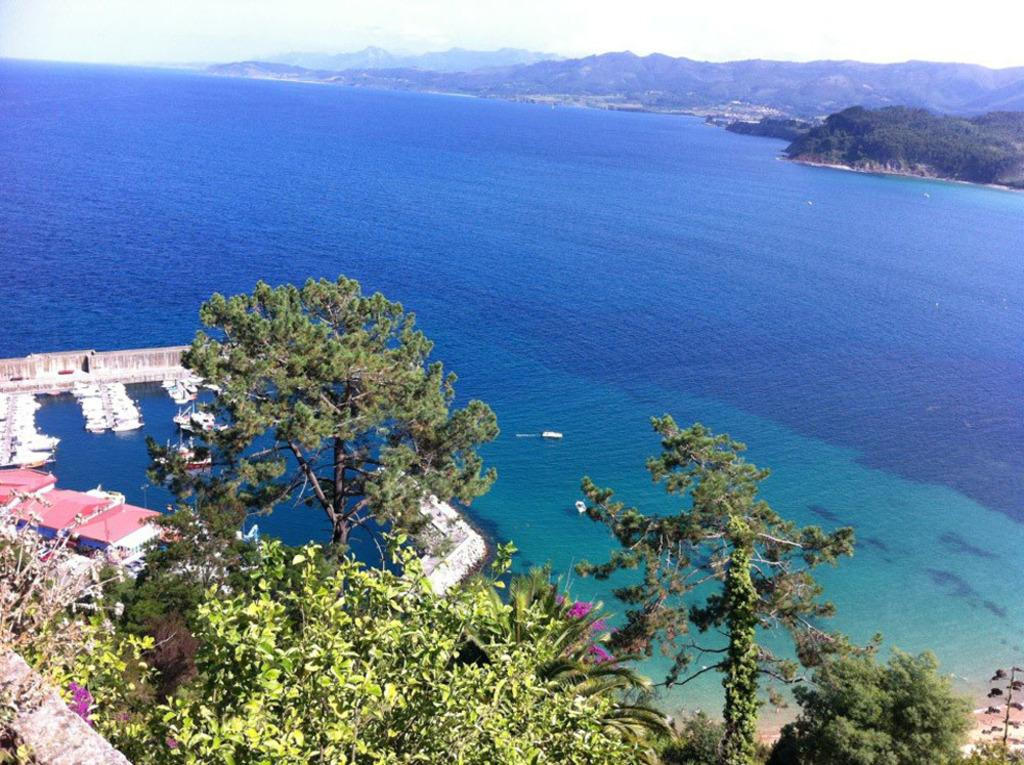What type of vegetation can be seen in the image? There are plants and trees in the image. What color are the plants and trees? The plants and trees are green. What is on the water in the image? There are boats on the water in the image. What can be seen in the distance in the image? There are mountains visible in the background of the image. What is the color of the sky in the image? The sky is white in color. Where is the father standing in the image? There is no father present in the image. What type of creature is the scarecrow interacting with in the image? There is no scarecrow present in the image. 